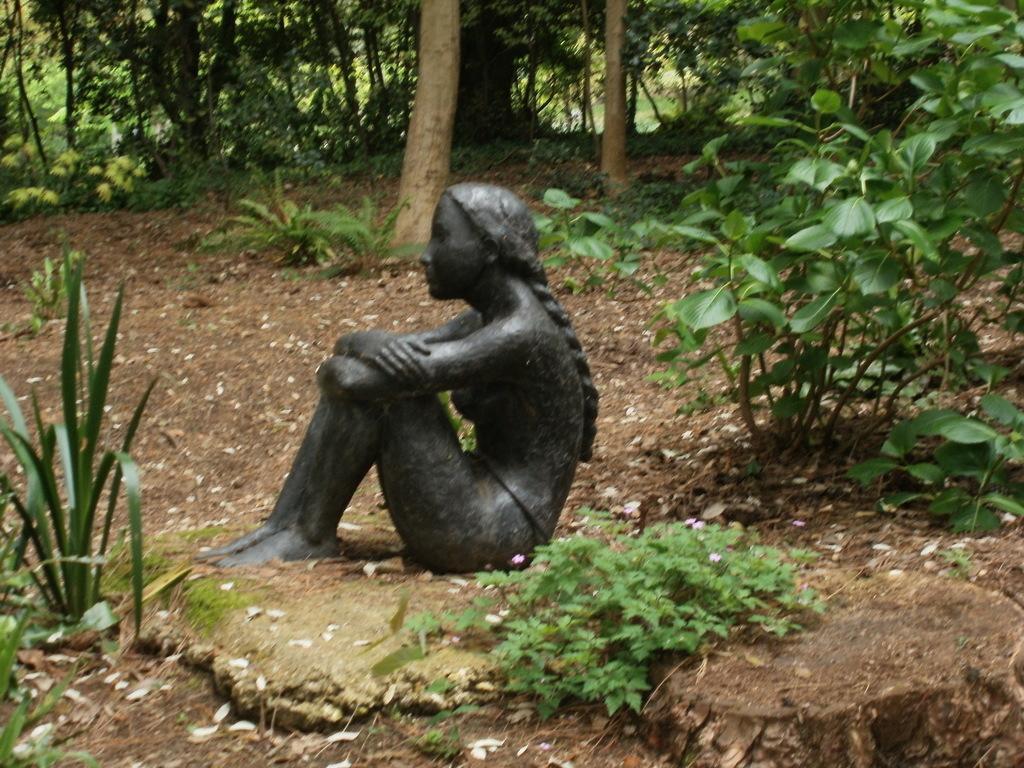Describe this image in one or two sentences. In this picture I can see the statue. I can see the plants. I can see trees. 